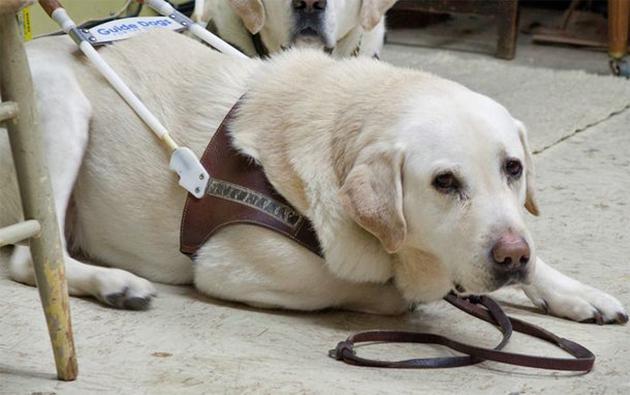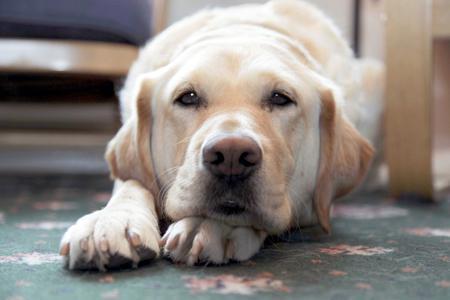The first image is the image on the left, the second image is the image on the right. Considering the images on both sides, is "There are six dogs in total." valid? Answer yes or no. No. The first image is the image on the left, the second image is the image on the right. Analyze the images presented: Is the assertion "A person's legs are visible behind at least one dog." valid? Answer yes or no. No. 